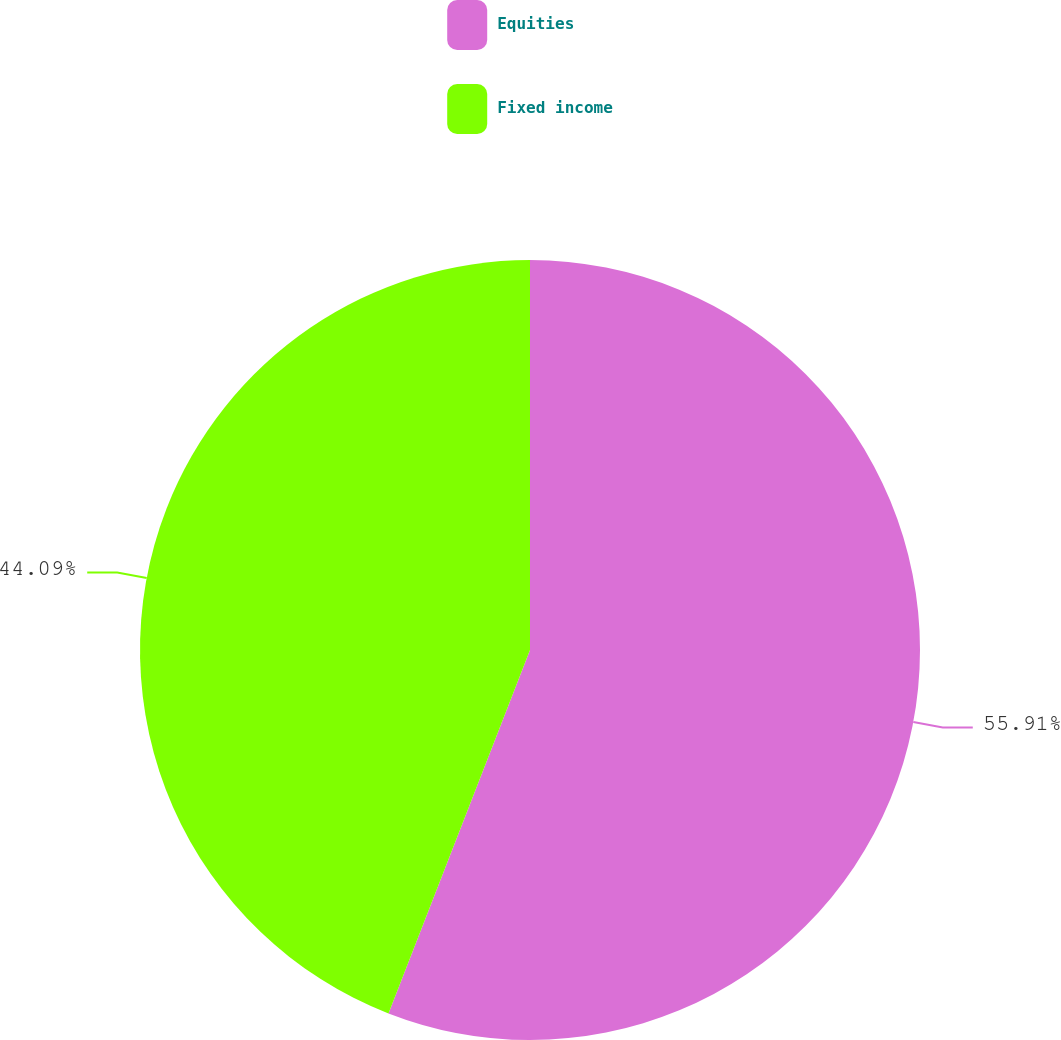Convert chart. <chart><loc_0><loc_0><loc_500><loc_500><pie_chart><fcel>Equities<fcel>Fixed income<nl><fcel>55.91%<fcel>44.09%<nl></chart> 